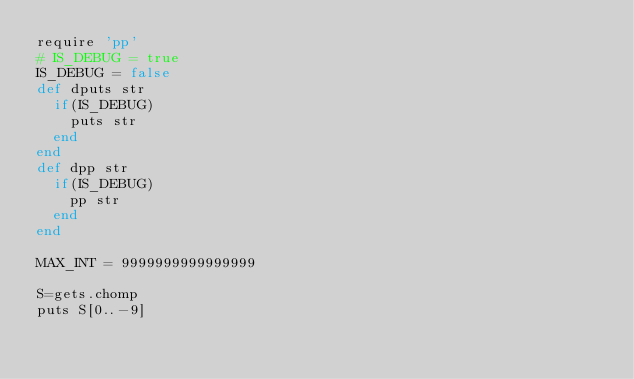<code> <loc_0><loc_0><loc_500><loc_500><_Ruby_>require 'pp'
# IS_DEBUG = true
IS_DEBUG = false
def dputs str
	if(IS_DEBUG)
		puts str
	end
end
def dpp str
	if(IS_DEBUG)
		pp str
	end
end

MAX_INT = 9999999999999999

S=gets.chomp
puts S[0..-9]</code> 